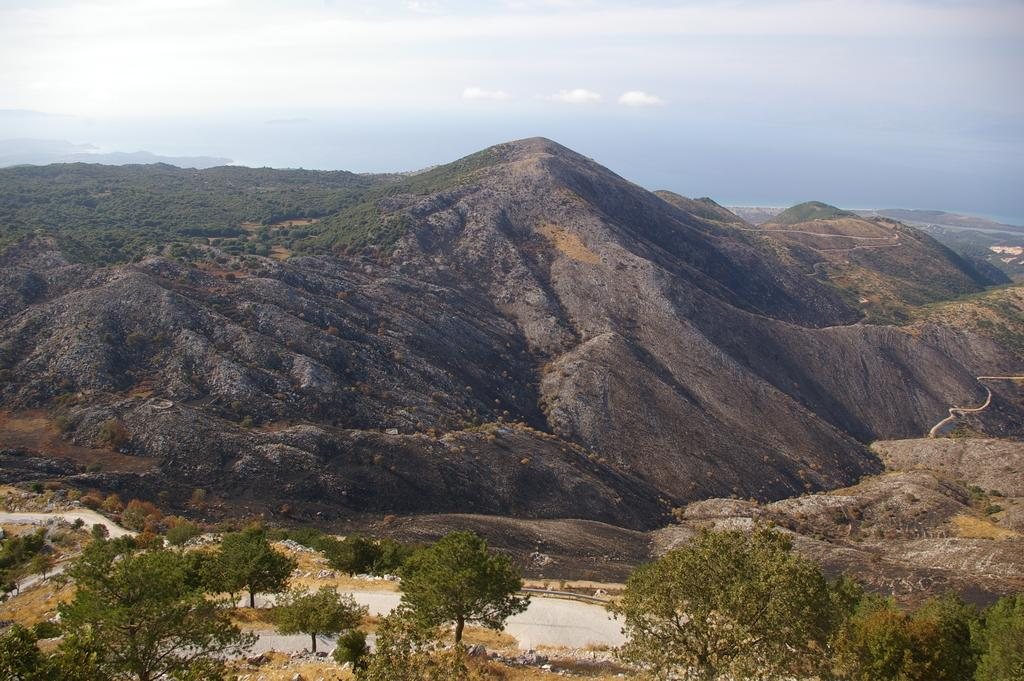What type of landscape is depicted at the bottom of the image? There are trees and sand at the bottom of the image. What geographical feature can be seen in the background of the image? There are mountains in the background of the image. What is visible at the top of the image? The sky is visible at the top of the image. What advice does the mother give to the person in the image? There is no person or mother present in the image, so it is not possible to answer that question. 